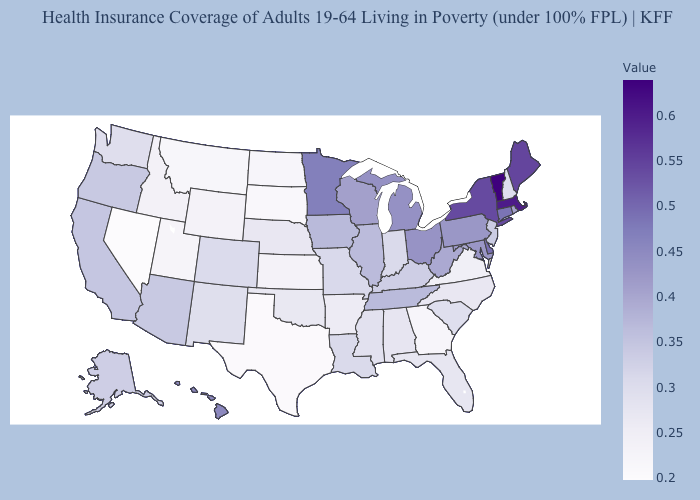Does Alaska have a higher value than Arkansas?
Keep it brief. Yes. Does the map have missing data?
Concise answer only. No. Does Vermont have the highest value in the Northeast?
Concise answer only. Yes. 